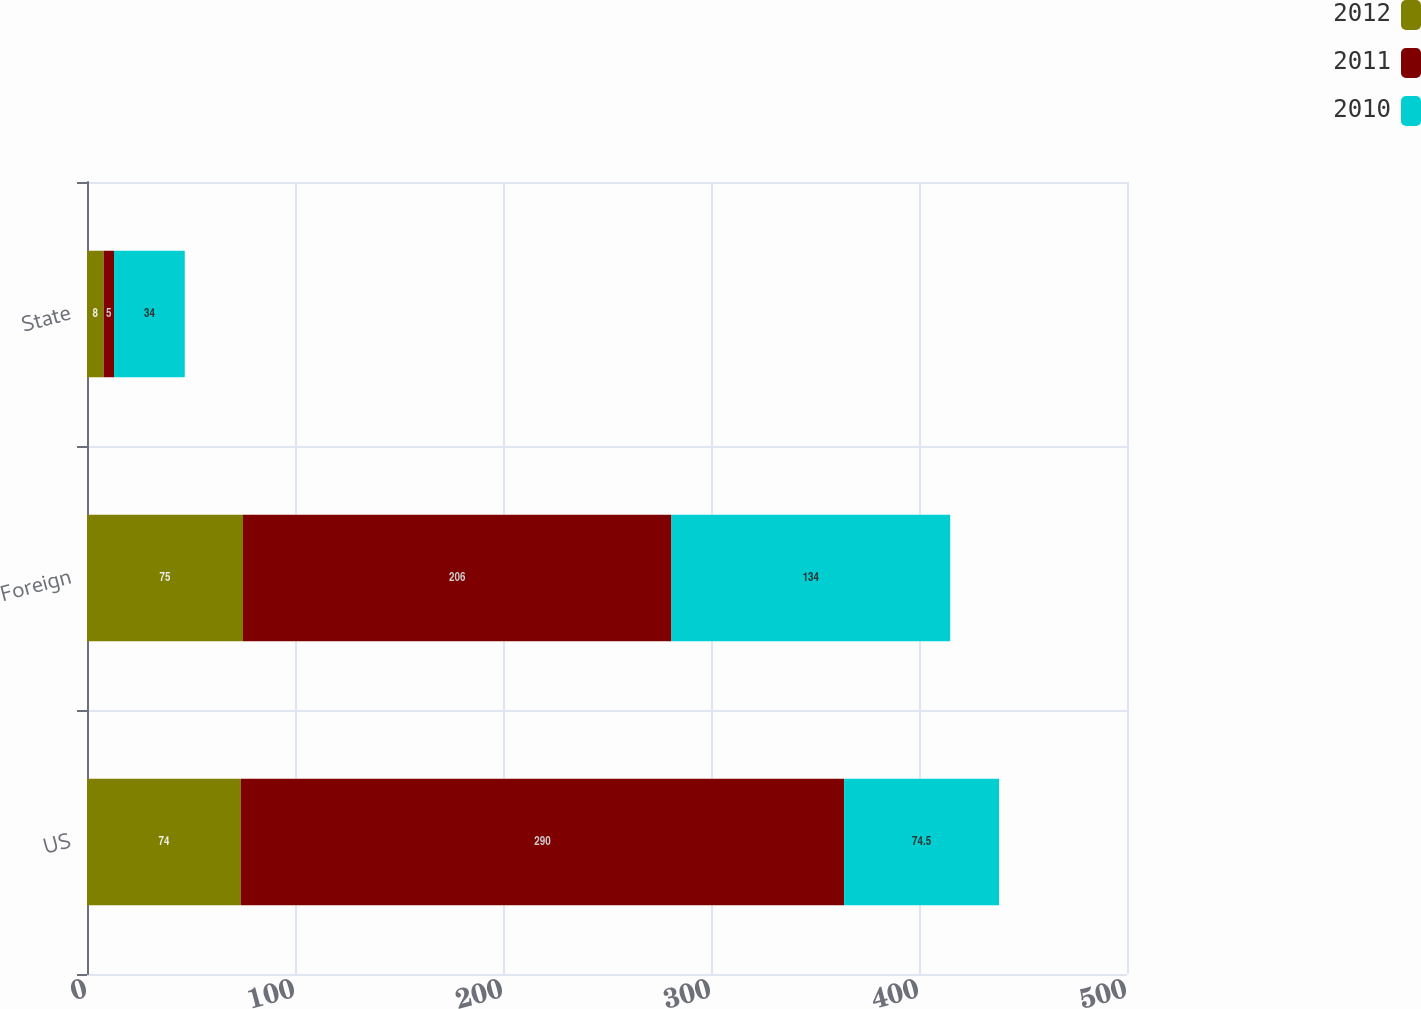<chart> <loc_0><loc_0><loc_500><loc_500><stacked_bar_chart><ecel><fcel>US<fcel>Foreign<fcel>State<nl><fcel>2012<fcel>74<fcel>75<fcel>8<nl><fcel>2011<fcel>290<fcel>206<fcel>5<nl><fcel>2010<fcel>74.5<fcel>134<fcel>34<nl></chart> 